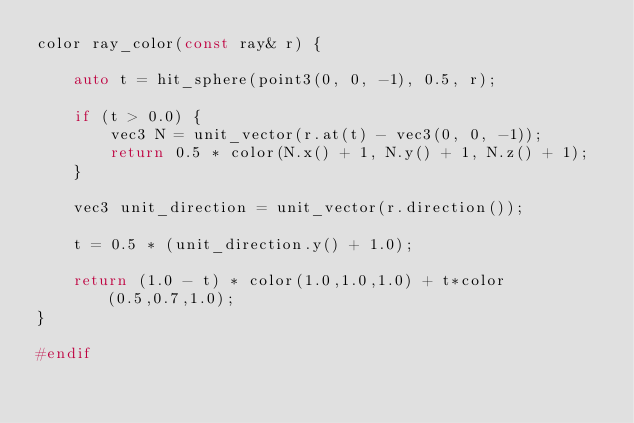Convert code to text. <code><loc_0><loc_0><loc_500><loc_500><_C_>color ray_color(const ray& r) {

    auto t = hit_sphere(point3(0, 0, -1), 0.5, r);

    if (t > 0.0) {
        vec3 N = unit_vector(r.at(t) - vec3(0, 0, -1));
        return 0.5 * color(N.x() + 1, N.y() + 1, N.z() + 1);
    }
    
    vec3 unit_direction = unit_vector(r.direction());
    
    t = 0.5 * (unit_direction.y() + 1.0);

    return (1.0 - t) * color(1.0,1.0,1.0) + t*color(0.5,0.7,1.0);
}

#endif</code> 